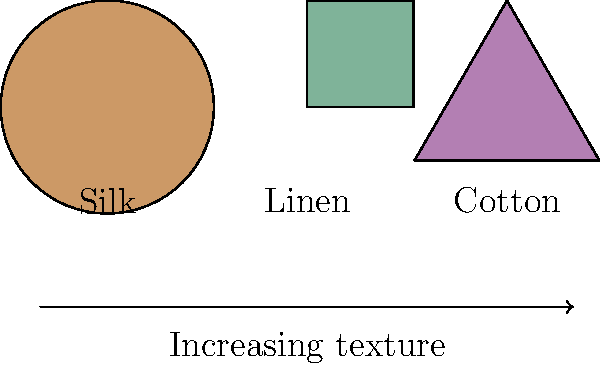Based on the fabric swatches shown above, which combination would create the most cohesive texture progression for a gender-neutral clothing line, considering the increasing texture from left to right? To determine the most cohesive texture progression for a gender-neutral clothing line, we need to consider the following steps:

1. Analyze the textures:
   - Silk (left): Smooth and lustrous
   - Linen (center): Medium texture with visible weave
   - Cotton (right): Soft but more textured than silk

2. Consider the progression:
   The arrow indicates increasing texture from left to right.

3. Evaluate gender-neutral aspects:
   All three fabrics are suitable for gender-neutral clothing, as they don't have inherently masculine or feminine associations.

4. Determine the best order:
   To create a cohesive progression, we should arrange the fabrics from smoothest to most textured:
   Silk → Linen → Cotton

5. Consider design applications:
   - Silk: Used for flowing, draped pieces
   - Linen: Ideal for structured yet breathable items
   - Cotton: Versatile for both structured and relaxed styles

6. Conclusion:
   The most cohesive texture progression would be to use all three fabrics in the order shown: Silk, Linen, Cotton. This creates a smooth transition from lustrous to more textured fabrics, allowing for a diverse yet cohesive collection.
Answer: Silk, Linen, Cotton 